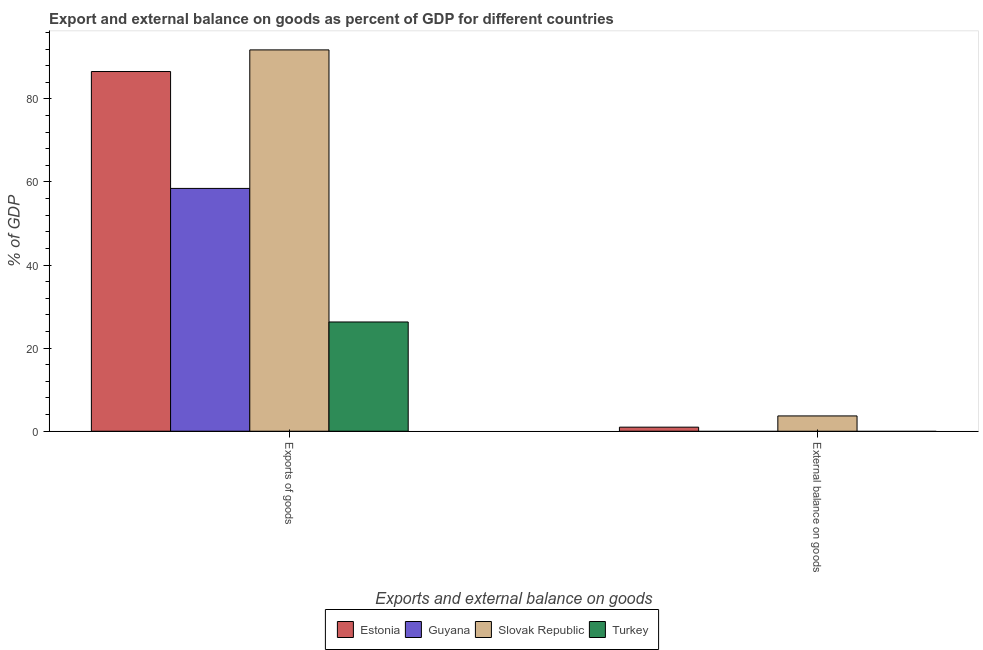How many different coloured bars are there?
Ensure brevity in your answer.  4. Are the number of bars per tick equal to the number of legend labels?
Your response must be concise. No. Are the number of bars on each tick of the X-axis equal?
Provide a short and direct response. No. How many bars are there on the 1st tick from the left?
Make the answer very short. 4. How many bars are there on the 2nd tick from the right?
Your answer should be very brief. 4. What is the label of the 2nd group of bars from the left?
Provide a short and direct response. External balance on goods. What is the export of goods as percentage of gdp in Slovak Republic?
Provide a short and direct response. 91.79. Across all countries, what is the maximum export of goods as percentage of gdp?
Offer a terse response. 91.79. Across all countries, what is the minimum export of goods as percentage of gdp?
Your response must be concise. 26.3. In which country was the export of goods as percentage of gdp maximum?
Your answer should be very brief. Slovak Republic. What is the total external balance on goods as percentage of gdp in the graph?
Offer a terse response. 4.66. What is the difference between the export of goods as percentage of gdp in Estonia and that in Slovak Republic?
Provide a short and direct response. -5.21. What is the difference between the external balance on goods as percentage of gdp in Estonia and the export of goods as percentage of gdp in Slovak Republic?
Offer a very short reply. -90.81. What is the average export of goods as percentage of gdp per country?
Offer a terse response. 65.78. What is the difference between the external balance on goods as percentage of gdp and export of goods as percentage of gdp in Estonia?
Provide a succinct answer. -85.6. In how many countries, is the external balance on goods as percentage of gdp greater than 4 %?
Provide a succinct answer. 0. What is the ratio of the export of goods as percentage of gdp in Turkey to that in Slovak Republic?
Ensure brevity in your answer.  0.29. In how many countries, is the external balance on goods as percentage of gdp greater than the average external balance on goods as percentage of gdp taken over all countries?
Make the answer very short. 1. How many bars are there?
Offer a very short reply. 6. How many countries are there in the graph?
Ensure brevity in your answer.  4. Does the graph contain any zero values?
Ensure brevity in your answer.  Yes. How many legend labels are there?
Provide a succinct answer. 4. What is the title of the graph?
Offer a terse response. Export and external balance on goods as percent of GDP for different countries. What is the label or title of the X-axis?
Ensure brevity in your answer.  Exports and external balance on goods. What is the label or title of the Y-axis?
Keep it short and to the point. % of GDP. What is the % of GDP of Estonia in Exports of goods?
Keep it short and to the point. 86.58. What is the % of GDP in Guyana in Exports of goods?
Your answer should be very brief. 58.45. What is the % of GDP in Slovak Republic in Exports of goods?
Give a very brief answer. 91.79. What is the % of GDP in Turkey in Exports of goods?
Provide a succinct answer. 26.3. What is the % of GDP in Estonia in External balance on goods?
Your response must be concise. 0.98. What is the % of GDP of Guyana in External balance on goods?
Your response must be concise. 0. What is the % of GDP of Slovak Republic in External balance on goods?
Provide a succinct answer. 3.68. What is the % of GDP in Turkey in External balance on goods?
Keep it short and to the point. 0. Across all Exports and external balance on goods, what is the maximum % of GDP in Estonia?
Your answer should be compact. 86.58. Across all Exports and external balance on goods, what is the maximum % of GDP in Guyana?
Offer a terse response. 58.45. Across all Exports and external balance on goods, what is the maximum % of GDP in Slovak Republic?
Give a very brief answer. 91.79. Across all Exports and external balance on goods, what is the maximum % of GDP in Turkey?
Make the answer very short. 26.3. Across all Exports and external balance on goods, what is the minimum % of GDP of Estonia?
Give a very brief answer. 0.98. Across all Exports and external balance on goods, what is the minimum % of GDP in Slovak Republic?
Your answer should be very brief. 3.68. Across all Exports and external balance on goods, what is the minimum % of GDP of Turkey?
Your answer should be very brief. 0. What is the total % of GDP of Estonia in the graph?
Make the answer very short. 87.56. What is the total % of GDP in Guyana in the graph?
Make the answer very short. 58.45. What is the total % of GDP in Slovak Republic in the graph?
Provide a succinct answer. 95.47. What is the total % of GDP in Turkey in the graph?
Provide a succinct answer. 26.3. What is the difference between the % of GDP in Estonia in Exports of goods and that in External balance on goods?
Offer a terse response. 85.6. What is the difference between the % of GDP of Slovak Republic in Exports of goods and that in External balance on goods?
Provide a succinct answer. 88.11. What is the difference between the % of GDP in Estonia in Exports of goods and the % of GDP in Slovak Republic in External balance on goods?
Keep it short and to the point. 82.9. What is the difference between the % of GDP in Guyana in Exports of goods and the % of GDP in Slovak Republic in External balance on goods?
Give a very brief answer. 54.76. What is the average % of GDP of Estonia per Exports and external balance on goods?
Ensure brevity in your answer.  43.78. What is the average % of GDP of Guyana per Exports and external balance on goods?
Ensure brevity in your answer.  29.22. What is the average % of GDP in Slovak Republic per Exports and external balance on goods?
Your answer should be very brief. 47.73. What is the average % of GDP in Turkey per Exports and external balance on goods?
Give a very brief answer. 13.15. What is the difference between the % of GDP of Estonia and % of GDP of Guyana in Exports of goods?
Offer a very short reply. 28.14. What is the difference between the % of GDP in Estonia and % of GDP in Slovak Republic in Exports of goods?
Your answer should be compact. -5.21. What is the difference between the % of GDP in Estonia and % of GDP in Turkey in Exports of goods?
Your response must be concise. 60.29. What is the difference between the % of GDP of Guyana and % of GDP of Slovak Republic in Exports of goods?
Keep it short and to the point. -33.34. What is the difference between the % of GDP in Guyana and % of GDP in Turkey in Exports of goods?
Your response must be concise. 32.15. What is the difference between the % of GDP in Slovak Republic and % of GDP in Turkey in Exports of goods?
Offer a terse response. 65.49. What is the difference between the % of GDP in Estonia and % of GDP in Slovak Republic in External balance on goods?
Your answer should be compact. -2.7. What is the ratio of the % of GDP of Estonia in Exports of goods to that in External balance on goods?
Your response must be concise. 88.49. What is the ratio of the % of GDP of Slovak Republic in Exports of goods to that in External balance on goods?
Provide a short and direct response. 24.94. What is the difference between the highest and the second highest % of GDP in Estonia?
Your answer should be very brief. 85.6. What is the difference between the highest and the second highest % of GDP of Slovak Republic?
Ensure brevity in your answer.  88.11. What is the difference between the highest and the lowest % of GDP of Estonia?
Ensure brevity in your answer.  85.6. What is the difference between the highest and the lowest % of GDP in Guyana?
Make the answer very short. 58.45. What is the difference between the highest and the lowest % of GDP of Slovak Republic?
Your response must be concise. 88.11. What is the difference between the highest and the lowest % of GDP of Turkey?
Give a very brief answer. 26.3. 